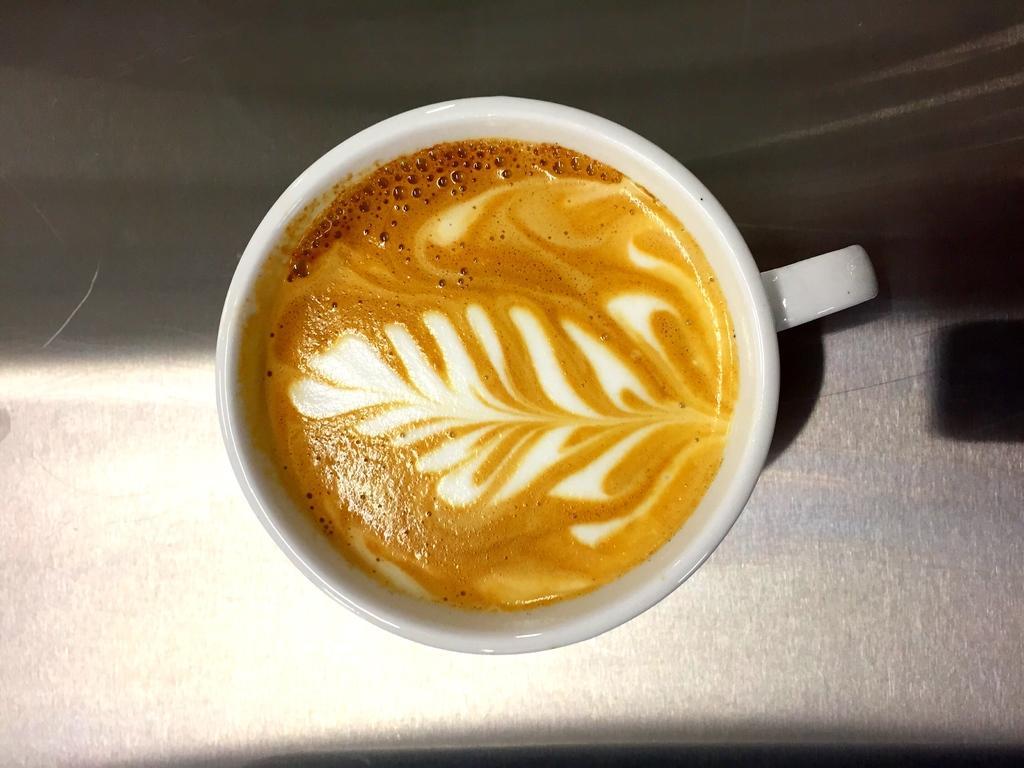In one or two sentences, can you explain what this image depicts? In this picture I can see there is a cup of coffee placed on a surface. 